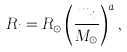<formula> <loc_0><loc_0><loc_500><loc_500>R _ { i } = R _ { \odot } \left ( \frac { m _ { i } } { M _ { \odot } } \right ) ^ { a } ,</formula> 